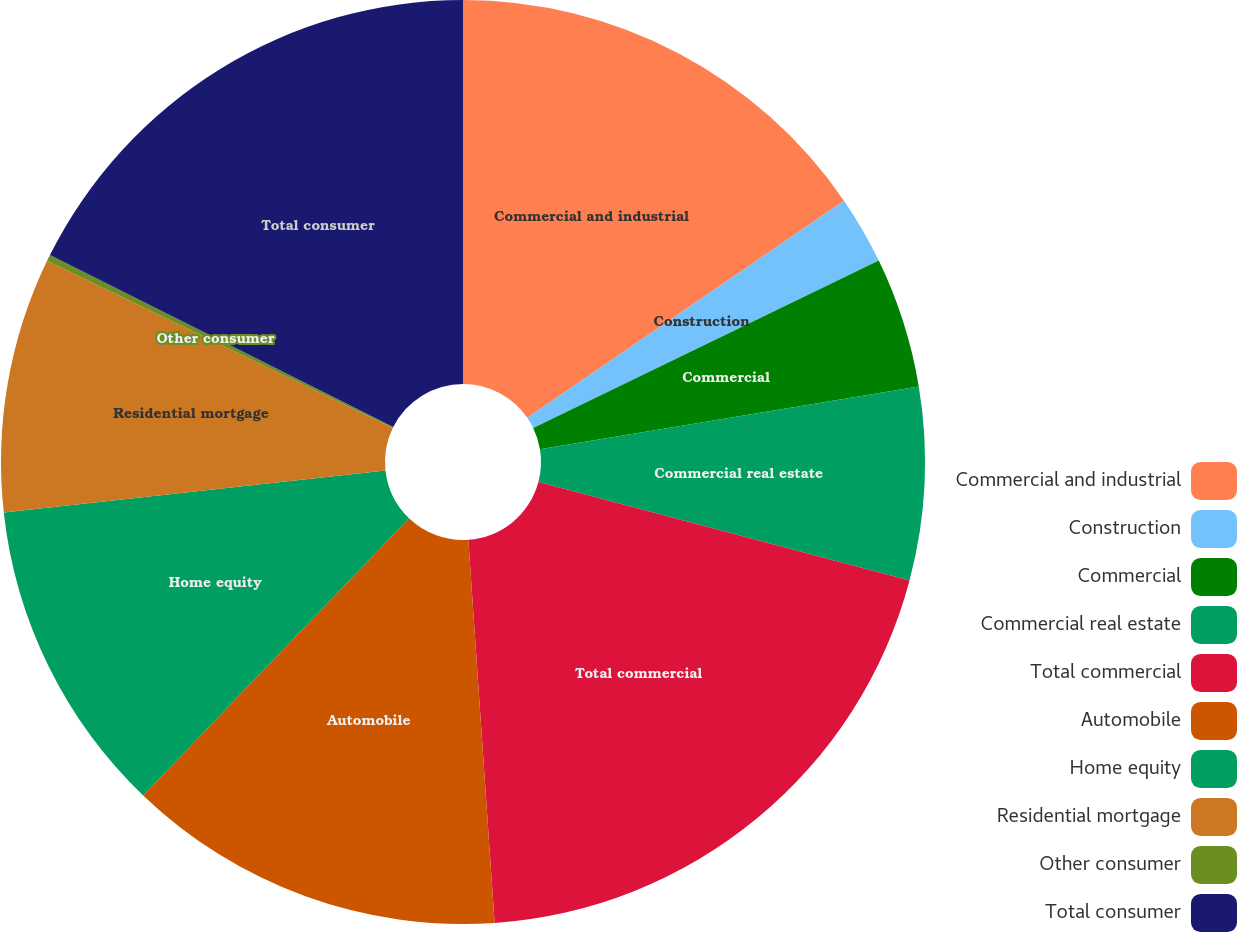Convert chart. <chart><loc_0><loc_0><loc_500><loc_500><pie_chart><fcel>Commercial and industrial<fcel>Construction<fcel>Commercial<fcel>Commercial real estate<fcel>Total commercial<fcel>Automobile<fcel>Home equity<fcel>Residential mortgage<fcel>Other consumer<fcel>Total consumer<nl><fcel>15.43%<fcel>2.39%<fcel>4.57%<fcel>6.74%<fcel>19.78%<fcel>13.26%<fcel>11.09%<fcel>8.91%<fcel>0.22%<fcel>17.61%<nl></chart> 